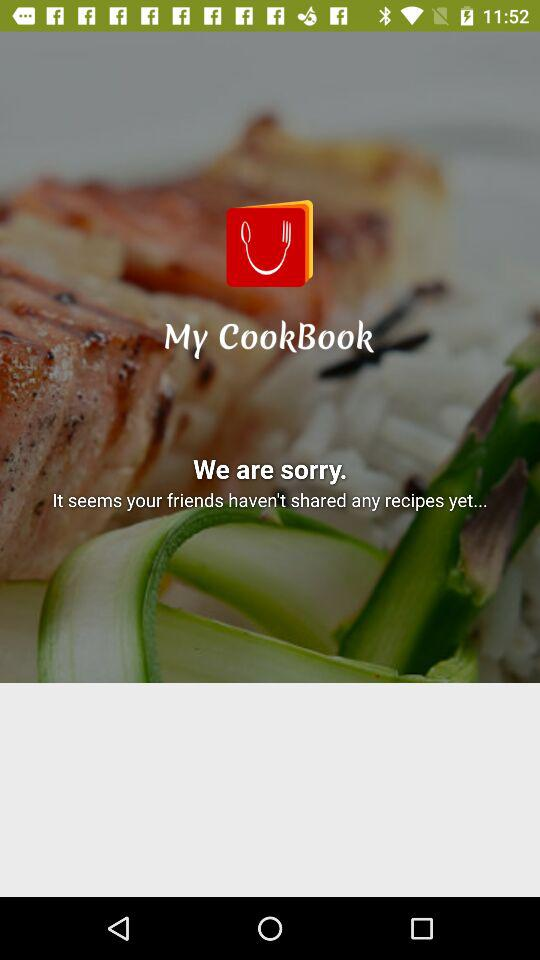Is there any recipie shared?
When the provided information is insufficient, respond with <no answer>. <no answer> 